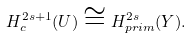Convert formula to latex. <formula><loc_0><loc_0><loc_500><loc_500>H ^ { 2 s + 1 } _ { c } ( U ) \cong H ^ { 2 s } _ { p r i m } ( Y ) .</formula> 